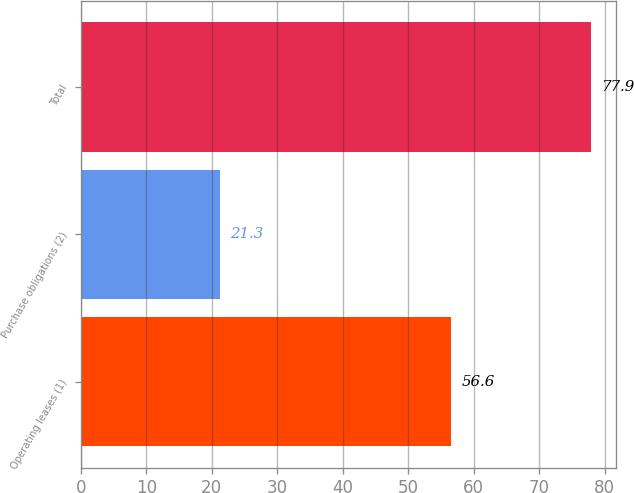Convert chart. <chart><loc_0><loc_0><loc_500><loc_500><bar_chart><fcel>Operating leases (1)<fcel>Purchase obligations (2)<fcel>Total<nl><fcel>56.6<fcel>21.3<fcel>77.9<nl></chart> 